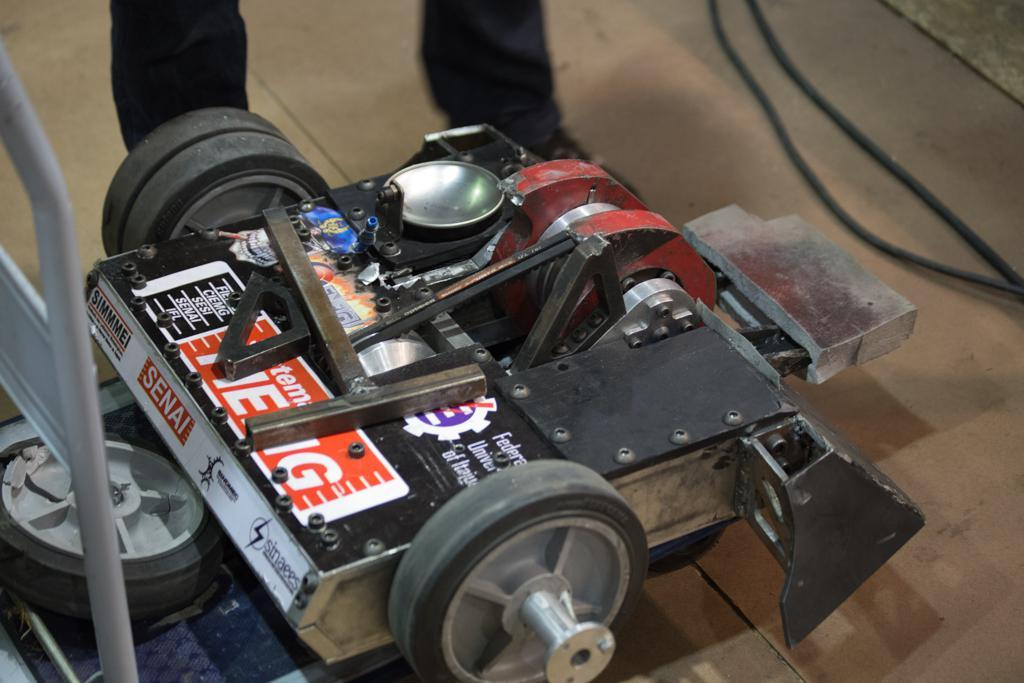What type of object with wheels is present in the image? There is a machine with wheels in the image. What else can be seen in the image besides the machine with wheels? There are wires visible in the image. Whose legs are visible in the image? A person's legs are visible in the image. What is the surface that the machine with wheels and person's legs are on? There is a floor in the image. How does the person in the image start their day? The image does not provide information about how the person starts their day or any details about the person beyond their legs being visible. 